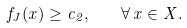Convert formula to latex. <formula><loc_0><loc_0><loc_500><loc_500>f _ { J } ( x ) \geq c _ { 2 } , \quad \forall \, x \in X .</formula> 